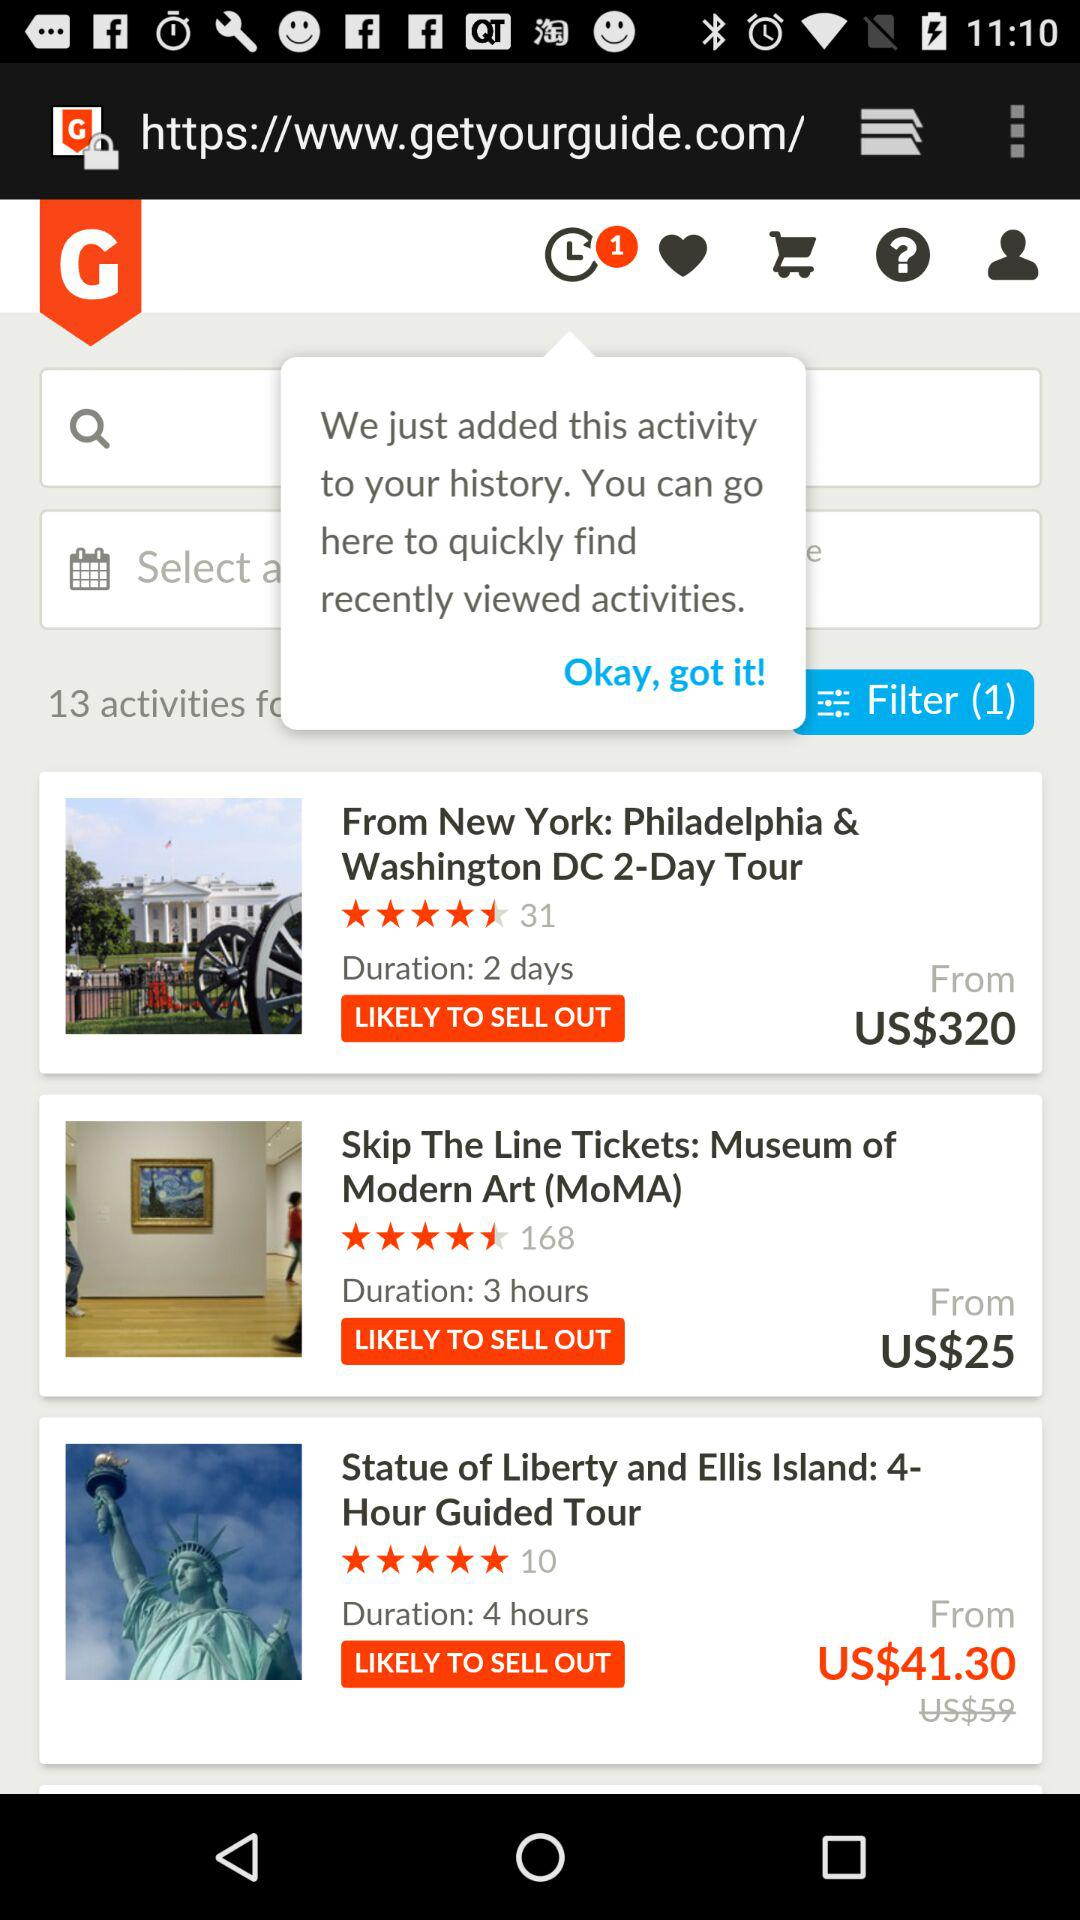How many filters are applied? There is 1 filter applied. 